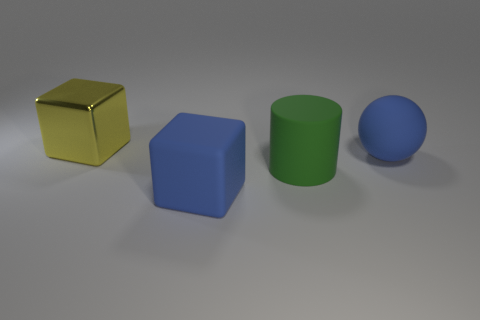What is the shape of the big thing that is to the left of the cube that is in front of the object left of the rubber cube?
Offer a terse response. Cube. Is there a yellow block that has the same size as the green object?
Offer a terse response. Yes. How big is the yellow object?
Make the answer very short. Large. How many blue objects have the same size as the blue sphere?
Offer a very short reply. 1. Is the number of big objects to the left of the big yellow shiny block less than the number of blue balls that are in front of the big blue rubber block?
Your answer should be compact. No. There is a blue object that is in front of the blue object that is behind the large blue rubber thing that is in front of the matte sphere; what is its size?
Make the answer very short. Large. What is the size of the thing that is left of the rubber cylinder and in front of the metal object?
Give a very brief answer. Large. There is a big thing that is behind the blue thing behind the large matte block; what shape is it?
Offer a terse response. Cube. Are there any other things that are the same color as the large matte ball?
Provide a succinct answer. Yes. What shape is the blue object that is to the left of the big ball?
Provide a short and direct response. Cube. 